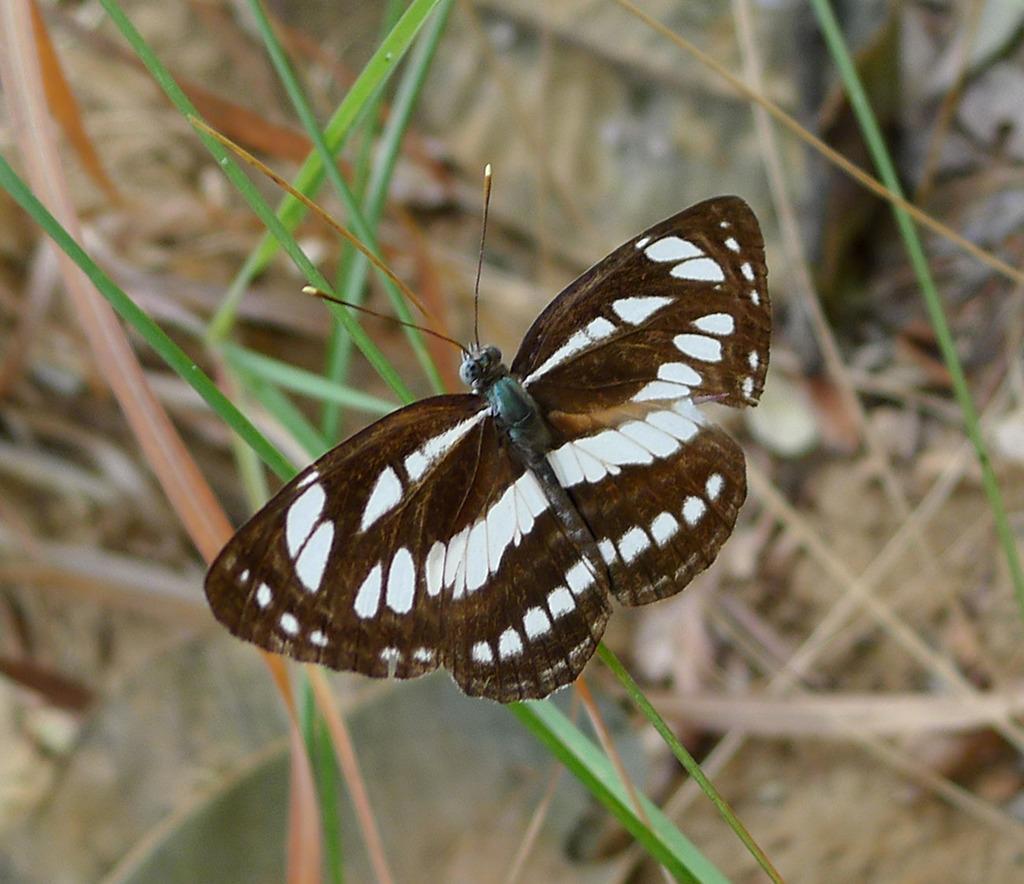In one or two sentences, can you explain what this image depicts? This picture shows a butterfly on the grass. It is White and Brown in color. 